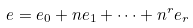Convert formula to latex. <formula><loc_0><loc_0><loc_500><loc_500>e = e _ { 0 } + n e _ { 1 } + \dots + n ^ { r } e _ { r }</formula> 